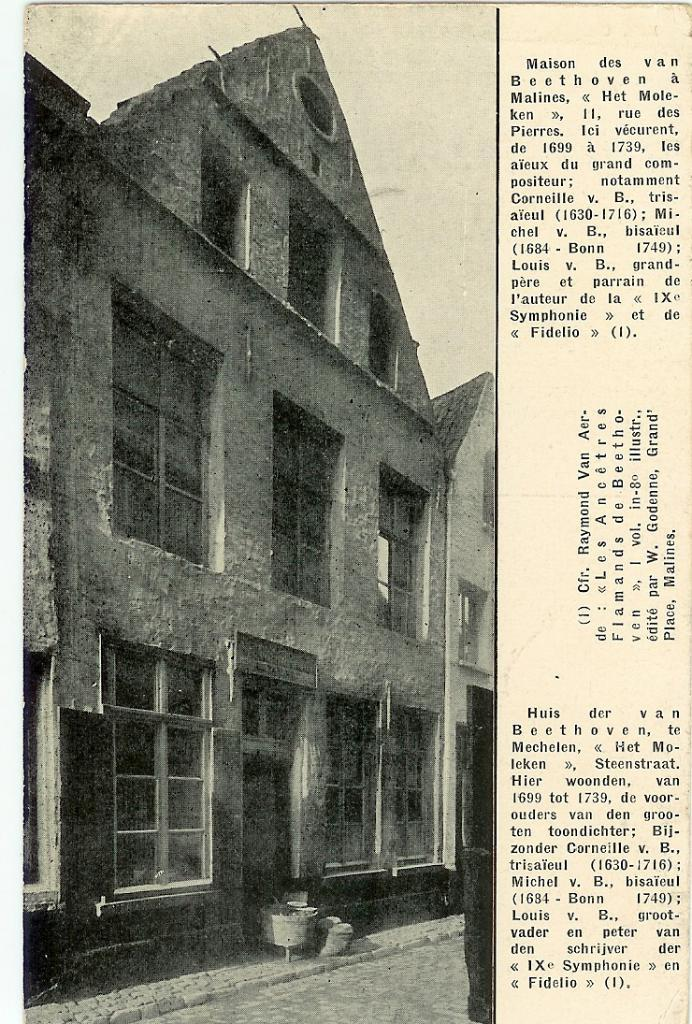What is depicted on the paper in the image? The paper contains a drawing of a building. What specific feature of the building is shown in the drawing? The building has windows. Is there any text on the paper? Yes, there is writing on the right side of the paper. What type of sponge can be seen in the drawing of the building? There is no sponge present in the drawing of the building; it only depicts a building with windows. 